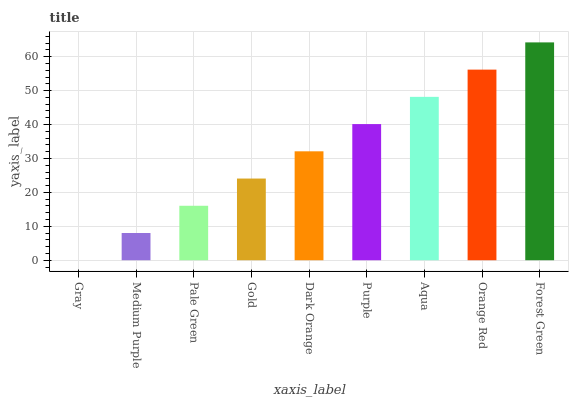Is Gray the minimum?
Answer yes or no. Yes. Is Forest Green the maximum?
Answer yes or no. Yes. Is Medium Purple the minimum?
Answer yes or no. No. Is Medium Purple the maximum?
Answer yes or no. No. Is Medium Purple greater than Gray?
Answer yes or no. Yes. Is Gray less than Medium Purple?
Answer yes or no. Yes. Is Gray greater than Medium Purple?
Answer yes or no. No. Is Medium Purple less than Gray?
Answer yes or no. No. Is Dark Orange the high median?
Answer yes or no. Yes. Is Dark Orange the low median?
Answer yes or no. Yes. Is Forest Green the high median?
Answer yes or no. No. Is Orange Red the low median?
Answer yes or no. No. 